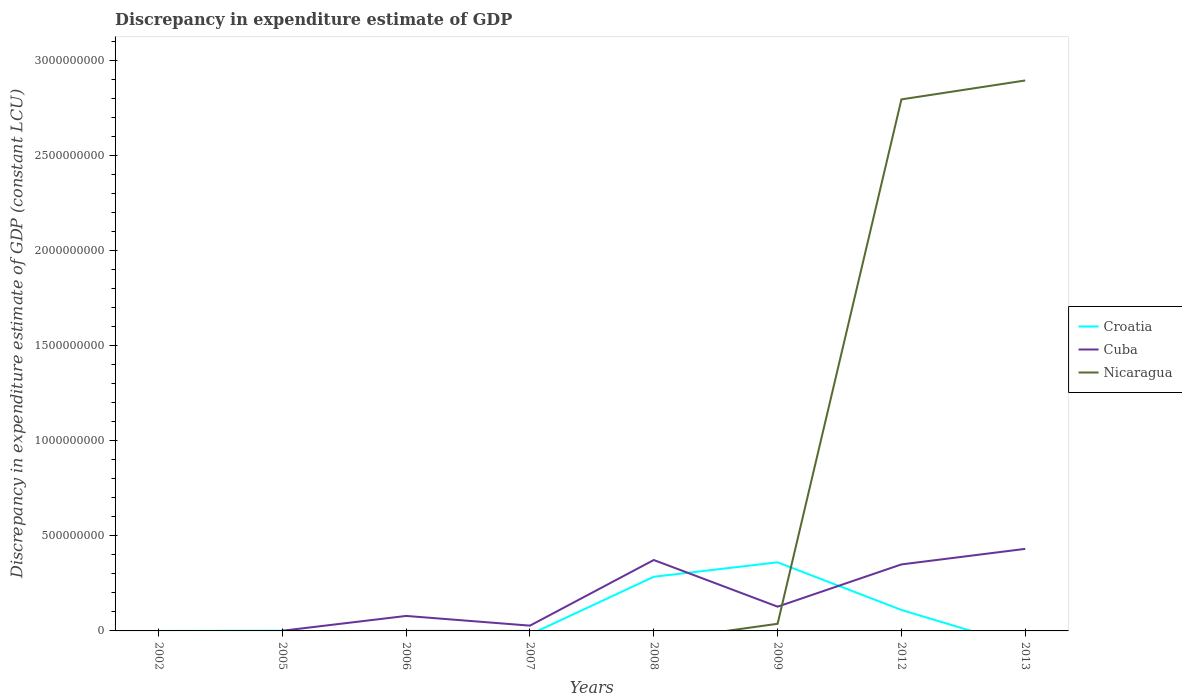How many different coloured lines are there?
Offer a very short reply. 3. Is the number of lines equal to the number of legend labels?
Make the answer very short. No. What is the total discrepancy in expenditure estimate of GDP in Cuba in the graph?
Offer a very short reply. -2.71e+08. What is the difference between the highest and the second highest discrepancy in expenditure estimate of GDP in Cuba?
Your response must be concise. 4.32e+08. Is the discrepancy in expenditure estimate of GDP in Nicaragua strictly greater than the discrepancy in expenditure estimate of GDP in Croatia over the years?
Offer a very short reply. No. How many years are there in the graph?
Offer a very short reply. 8. What is the difference between two consecutive major ticks on the Y-axis?
Make the answer very short. 5.00e+08. Does the graph contain any zero values?
Provide a succinct answer. Yes. What is the title of the graph?
Give a very brief answer. Discrepancy in expenditure estimate of GDP. What is the label or title of the Y-axis?
Your answer should be compact. Discrepancy in expenditure estimate of GDP (constant LCU). What is the Discrepancy in expenditure estimate of GDP (constant LCU) in Croatia in 2005?
Provide a short and direct response. 1.00e+06. What is the Discrepancy in expenditure estimate of GDP (constant LCU) of Cuba in 2005?
Your response must be concise. 9.00e+05. What is the Discrepancy in expenditure estimate of GDP (constant LCU) in Nicaragua in 2005?
Give a very brief answer. 0. What is the Discrepancy in expenditure estimate of GDP (constant LCU) in Cuba in 2006?
Offer a terse response. 7.89e+07. What is the Discrepancy in expenditure estimate of GDP (constant LCU) in Nicaragua in 2006?
Your answer should be compact. 0. What is the Discrepancy in expenditure estimate of GDP (constant LCU) of Cuba in 2007?
Your answer should be compact. 2.78e+07. What is the Discrepancy in expenditure estimate of GDP (constant LCU) in Croatia in 2008?
Provide a short and direct response. 2.85e+08. What is the Discrepancy in expenditure estimate of GDP (constant LCU) in Cuba in 2008?
Make the answer very short. 3.73e+08. What is the Discrepancy in expenditure estimate of GDP (constant LCU) in Nicaragua in 2008?
Give a very brief answer. 0. What is the Discrepancy in expenditure estimate of GDP (constant LCU) of Croatia in 2009?
Offer a terse response. 3.61e+08. What is the Discrepancy in expenditure estimate of GDP (constant LCU) of Cuba in 2009?
Give a very brief answer. 1.28e+08. What is the Discrepancy in expenditure estimate of GDP (constant LCU) of Nicaragua in 2009?
Your answer should be very brief. 3.76e+07. What is the Discrepancy in expenditure estimate of GDP (constant LCU) in Croatia in 2012?
Ensure brevity in your answer.  1.10e+08. What is the Discrepancy in expenditure estimate of GDP (constant LCU) in Cuba in 2012?
Make the answer very short. 3.50e+08. What is the Discrepancy in expenditure estimate of GDP (constant LCU) in Nicaragua in 2012?
Provide a succinct answer. 2.80e+09. What is the Discrepancy in expenditure estimate of GDP (constant LCU) of Croatia in 2013?
Your response must be concise. 0. What is the Discrepancy in expenditure estimate of GDP (constant LCU) in Cuba in 2013?
Offer a very short reply. 4.32e+08. What is the Discrepancy in expenditure estimate of GDP (constant LCU) in Nicaragua in 2013?
Make the answer very short. 2.90e+09. Across all years, what is the maximum Discrepancy in expenditure estimate of GDP (constant LCU) in Croatia?
Make the answer very short. 3.61e+08. Across all years, what is the maximum Discrepancy in expenditure estimate of GDP (constant LCU) in Cuba?
Provide a succinct answer. 4.32e+08. Across all years, what is the maximum Discrepancy in expenditure estimate of GDP (constant LCU) of Nicaragua?
Make the answer very short. 2.90e+09. Across all years, what is the minimum Discrepancy in expenditure estimate of GDP (constant LCU) of Croatia?
Provide a succinct answer. 0. Across all years, what is the minimum Discrepancy in expenditure estimate of GDP (constant LCU) in Nicaragua?
Your answer should be very brief. 0. What is the total Discrepancy in expenditure estimate of GDP (constant LCU) of Croatia in the graph?
Provide a succinct answer. 7.57e+08. What is the total Discrepancy in expenditure estimate of GDP (constant LCU) of Cuba in the graph?
Provide a succinct answer. 1.39e+09. What is the total Discrepancy in expenditure estimate of GDP (constant LCU) in Nicaragua in the graph?
Make the answer very short. 5.73e+09. What is the difference between the Discrepancy in expenditure estimate of GDP (constant LCU) in Croatia in 2002 and that in 2005?
Give a very brief answer. -1.00e+06. What is the difference between the Discrepancy in expenditure estimate of GDP (constant LCU) of Croatia in 2002 and that in 2008?
Your answer should be very brief. -2.85e+08. What is the difference between the Discrepancy in expenditure estimate of GDP (constant LCU) of Croatia in 2002 and that in 2009?
Offer a terse response. -3.61e+08. What is the difference between the Discrepancy in expenditure estimate of GDP (constant LCU) in Croatia in 2002 and that in 2012?
Your answer should be very brief. -1.10e+08. What is the difference between the Discrepancy in expenditure estimate of GDP (constant LCU) of Cuba in 2005 and that in 2006?
Provide a succinct answer. -7.80e+07. What is the difference between the Discrepancy in expenditure estimate of GDP (constant LCU) of Cuba in 2005 and that in 2007?
Provide a succinct answer. -2.69e+07. What is the difference between the Discrepancy in expenditure estimate of GDP (constant LCU) in Croatia in 2005 and that in 2008?
Ensure brevity in your answer.  -2.84e+08. What is the difference between the Discrepancy in expenditure estimate of GDP (constant LCU) of Cuba in 2005 and that in 2008?
Provide a succinct answer. -3.72e+08. What is the difference between the Discrepancy in expenditure estimate of GDP (constant LCU) in Croatia in 2005 and that in 2009?
Keep it short and to the point. -3.60e+08. What is the difference between the Discrepancy in expenditure estimate of GDP (constant LCU) of Cuba in 2005 and that in 2009?
Provide a succinct answer. -1.27e+08. What is the difference between the Discrepancy in expenditure estimate of GDP (constant LCU) in Croatia in 2005 and that in 2012?
Offer a very short reply. -1.09e+08. What is the difference between the Discrepancy in expenditure estimate of GDP (constant LCU) in Cuba in 2005 and that in 2012?
Offer a very short reply. -3.49e+08. What is the difference between the Discrepancy in expenditure estimate of GDP (constant LCU) of Cuba in 2005 and that in 2013?
Your answer should be very brief. -4.31e+08. What is the difference between the Discrepancy in expenditure estimate of GDP (constant LCU) in Cuba in 2006 and that in 2007?
Offer a terse response. 5.11e+07. What is the difference between the Discrepancy in expenditure estimate of GDP (constant LCU) in Cuba in 2006 and that in 2008?
Give a very brief answer. -2.94e+08. What is the difference between the Discrepancy in expenditure estimate of GDP (constant LCU) of Cuba in 2006 and that in 2009?
Your answer should be compact. -4.87e+07. What is the difference between the Discrepancy in expenditure estimate of GDP (constant LCU) of Cuba in 2006 and that in 2012?
Offer a terse response. -2.71e+08. What is the difference between the Discrepancy in expenditure estimate of GDP (constant LCU) of Cuba in 2006 and that in 2013?
Your answer should be very brief. -3.53e+08. What is the difference between the Discrepancy in expenditure estimate of GDP (constant LCU) of Cuba in 2007 and that in 2008?
Offer a very short reply. -3.45e+08. What is the difference between the Discrepancy in expenditure estimate of GDP (constant LCU) in Cuba in 2007 and that in 2009?
Offer a terse response. -9.98e+07. What is the difference between the Discrepancy in expenditure estimate of GDP (constant LCU) in Cuba in 2007 and that in 2012?
Keep it short and to the point. -3.22e+08. What is the difference between the Discrepancy in expenditure estimate of GDP (constant LCU) in Cuba in 2007 and that in 2013?
Your answer should be compact. -4.04e+08. What is the difference between the Discrepancy in expenditure estimate of GDP (constant LCU) of Croatia in 2008 and that in 2009?
Your answer should be compact. -7.60e+07. What is the difference between the Discrepancy in expenditure estimate of GDP (constant LCU) of Cuba in 2008 and that in 2009?
Provide a short and direct response. 2.45e+08. What is the difference between the Discrepancy in expenditure estimate of GDP (constant LCU) of Croatia in 2008 and that in 2012?
Offer a terse response. 1.74e+08. What is the difference between the Discrepancy in expenditure estimate of GDP (constant LCU) in Cuba in 2008 and that in 2012?
Offer a terse response. 2.32e+07. What is the difference between the Discrepancy in expenditure estimate of GDP (constant LCU) of Cuba in 2008 and that in 2013?
Ensure brevity in your answer.  -5.86e+07. What is the difference between the Discrepancy in expenditure estimate of GDP (constant LCU) in Croatia in 2009 and that in 2012?
Your response must be concise. 2.50e+08. What is the difference between the Discrepancy in expenditure estimate of GDP (constant LCU) of Cuba in 2009 and that in 2012?
Your response must be concise. -2.22e+08. What is the difference between the Discrepancy in expenditure estimate of GDP (constant LCU) in Nicaragua in 2009 and that in 2012?
Ensure brevity in your answer.  -2.76e+09. What is the difference between the Discrepancy in expenditure estimate of GDP (constant LCU) in Cuba in 2009 and that in 2013?
Make the answer very short. -3.04e+08. What is the difference between the Discrepancy in expenditure estimate of GDP (constant LCU) of Nicaragua in 2009 and that in 2013?
Provide a short and direct response. -2.86e+09. What is the difference between the Discrepancy in expenditure estimate of GDP (constant LCU) of Cuba in 2012 and that in 2013?
Provide a succinct answer. -8.18e+07. What is the difference between the Discrepancy in expenditure estimate of GDP (constant LCU) of Nicaragua in 2012 and that in 2013?
Give a very brief answer. -9.95e+07. What is the difference between the Discrepancy in expenditure estimate of GDP (constant LCU) in Croatia in 2002 and the Discrepancy in expenditure estimate of GDP (constant LCU) in Cuba in 2005?
Make the answer very short. -9.00e+05. What is the difference between the Discrepancy in expenditure estimate of GDP (constant LCU) in Croatia in 2002 and the Discrepancy in expenditure estimate of GDP (constant LCU) in Cuba in 2006?
Your answer should be very brief. -7.89e+07. What is the difference between the Discrepancy in expenditure estimate of GDP (constant LCU) in Croatia in 2002 and the Discrepancy in expenditure estimate of GDP (constant LCU) in Cuba in 2007?
Provide a succinct answer. -2.78e+07. What is the difference between the Discrepancy in expenditure estimate of GDP (constant LCU) in Croatia in 2002 and the Discrepancy in expenditure estimate of GDP (constant LCU) in Cuba in 2008?
Make the answer very short. -3.73e+08. What is the difference between the Discrepancy in expenditure estimate of GDP (constant LCU) in Croatia in 2002 and the Discrepancy in expenditure estimate of GDP (constant LCU) in Cuba in 2009?
Keep it short and to the point. -1.28e+08. What is the difference between the Discrepancy in expenditure estimate of GDP (constant LCU) of Croatia in 2002 and the Discrepancy in expenditure estimate of GDP (constant LCU) of Nicaragua in 2009?
Provide a succinct answer. -3.76e+07. What is the difference between the Discrepancy in expenditure estimate of GDP (constant LCU) in Croatia in 2002 and the Discrepancy in expenditure estimate of GDP (constant LCU) in Cuba in 2012?
Offer a very short reply. -3.50e+08. What is the difference between the Discrepancy in expenditure estimate of GDP (constant LCU) in Croatia in 2002 and the Discrepancy in expenditure estimate of GDP (constant LCU) in Nicaragua in 2012?
Provide a short and direct response. -2.80e+09. What is the difference between the Discrepancy in expenditure estimate of GDP (constant LCU) in Croatia in 2002 and the Discrepancy in expenditure estimate of GDP (constant LCU) in Cuba in 2013?
Make the answer very short. -4.32e+08. What is the difference between the Discrepancy in expenditure estimate of GDP (constant LCU) in Croatia in 2002 and the Discrepancy in expenditure estimate of GDP (constant LCU) in Nicaragua in 2013?
Ensure brevity in your answer.  -2.90e+09. What is the difference between the Discrepancy in expenditure estimate of GDP (constant LCU) of Croatia in 2005 and the Discrepancy in expenditure estimate of GDP (constant LCU) of Cuba in 2006?
Give a very brief answer. -7.79e+07. What is the difference between the Discrepancy in expenditure estimate of GDP (constant LCU) of Croatia in 2005 and the Discrepancy in expenditure estimate of GDP (constant LCU) of Cuba in 2007?
Provide a short and direct response. -2.68e+07. What is the difference between the Discrepancy in expenditure estimate of GDP (constant LCU) in Croatia in 2005 and the Discrepancy in expenditure estimate of GDP (constant LCU) in Cuba in 2008?
Your answer should be very brief. -3.72e+08. What is the difference between the Discrepancy in expenditure estimate of GDP (constant LCU) in Croatia in 2005 and the Discrepancy in expenditure estimate of GDP (constant LCU) in Cuba in 2009?
Your answer should be very brief. -1.27e+08. What is the difference between the Discrepancy in expenditure estimate of GDP (constant LCU) in Croatia in 2005 and the Discrepancy in expenditure estimate of GDP (constant LCU) in Nicaragua in 2009?
Your answer should be compact. -3.66e+07. What is the difference between the Discrepancy in expenditure estimate of GDP (constant LCU) of Cuba in 2005 and the Discrepancy in expenditure estimate of GDP (constant LCU) of Nicaragua in 2009?
Provide a short and direct response. -3.67e+07. What is the difference between the Discrepancy in expenditure estimate of GDP (constant LCU) in Croatia in 2005 and the Discrepancy in expenditure estimate of GDP (constant LCU) in Cuba in 2012?
Offer a very short reply. -3.49e+08. What is the difference between the Discrepancy in expenditure estimate of GDP (constant LCU) in Croatia in 2005 and the Discrepancy in expenditure estimate of GDP (constant LCU) in Nicaragua in 2012?
Offer a terse response. -2.80e+09. What is the difference between the Discrepancy in expenditure estimate of GDP (constant LCU) of Cuba in 2005 and the Discrepancy in expenditure estimate of GDP (constant LCU) of Nicaragua in 2012?
Your answer should be very brief. -2.80e+09. What is the difference between the Discrepancy in expenditure estimate of GDP (constant LCU) of Croatia in 2005 and the Discrepancy in expenditure estimate of GDP (constant LCU) of Cuba in 2013?
Offer a very short reply. -4.31e+08. What is the difference between the Discrepancy in expenditure estimate of GDP (constant LCU) of Croatia in 2005 and the Discrepancy in expenditure estimate of GDP (constant LCU) of Nicaragua in 2013?
Give a very brief answer. -2.89e+09. What is the difference between the Discrepancy in expenditure estimate of GDP (constant LCU) in Cuba in 2005 and the Discrepancy in expenditure estimate of GDP (constant LCU) in Nicaragua in 2013?
Ensure brevity in your answer.  -2.89e+09. What is the difference between the Discrepancy in expenditure estimate of GDP (constant LCU) of Cuba in 2006 and the Discrepancy in expenditure estimate of GDP (constant LCU) of Nicaragua in 2009?
Offer a very short reply. 4.12e+07. What is the difference between the Discrepancy in expenditure estimate of GDP (constant LCU) in Cuba in 2006 and the Discrepancy in expenditure estimate of GDP (constant LCU) in Nicaragua in 2012?
Your answer should be very brief. -2.72e+09. What is the difference between the Discrepancy in expenditure estimate of GDP (constant LCU) in Cuba in 2006 and the Discrepancy in expenditure estimate of GDP (constant LCU) in Nicaragua in 2013?
Provide a succinct answer. -2.82e+09. What is the difference between the Discrepancy in expenditure estimate of GDP (constant LCU) in Cuba in 2007 and the Discrepancy in expenditure estimate of GDP (constant LCU) in Nicaragua in 2009?
Your answer should be very brief. -9.83e+06. What is the difference between the Discrepancy in expenditure estimate of GDP (constant LCU) in Cuba in 2007 and the Discrepancy in expenditure estimate of GDP (constant LCU) in Nicaragua in 2012?
Your answer should be very brief. -2.77e+09. What is the difference between the Discrepancy in expenditure estimate of GDP (constant LCU) of Cuba in 2007 and the Discrepancy in expenditure estimate of GDP (constant LCU) of Nicaragua in 2013?
Provide a short and direct response. -2.87e+09. What is the difference between the Discrepancy in expenditure estimate of GDP (constant LCU) in Croatia in 2008 and the Discrepancy in expenditure estimate of GDP (constant LCU) in Cuba in 2009?
Provide a succinct answer. 1.57e+08. What is the difference between the Discrepancy in expenditure estimate of GDP (constant LCU) in Croatia in 2008 and the Discrepancy in expenditure estimate of GDP (constant LCU) in Nicaragua in 2009?
Keep it short and to the point. 2.47e+08. What is the difference between the Discrepancy in expenditure estimate of GDP (constant LCU) in Cuba in 2008 and the Discrepancy in expenditure estimate of GDP (constant LCU) in Nicaragua in 2009?
Your response must be concise. 3.35e+08. What is the difference between the Discrepancy in expenditure estimate of GDP (constant LCU) of Croatia in 2008 and the Discrepancy in expenditure estimate of GDP (constant LCU) of Cuba in 2012?
Provide a short and direct response. -6.50e+07. What is the difference between the Discrepancy in expenditure estimate of GDP (constant LCU) in Croatia in 2008 and the Discrepancy in expenditure estimate of GDP (constant LCU) in Nicaragua in 2012?
Ensure brevity in your answer.  -2.51e+09. What is the difference between the Discrepancy in expenditure estimate of GDP (constant LCU) of Cuba in 2008 and the Discrepancy in expenditure estimate of GDP (constant LCU) of Nicaragua in 2012?
Offer a terse response. -2.42e+09. What is the difference between the Discrepancy in expenditure estimate of GDP (constant LCU) in Croatia in 2008 and the Discrepancy in expenditure estimate of GDP (constant LCU) in Cuba in 2013?
Make the answer very short. -1.47e+08. What is the difference between the Discrepancy in expenditure estimate of GDP (constant LCU) in Croatia in 2008 and the Discrepancy in expenditure estimate of GDP (constant LCU) in Nicaragua in 2013?
Keep it short and to the point. -2.61e+09. What is the difference between the Discrepancy in expenditure estimate of GDP (constant LCU) in Cuba in 2008 and the Discrepancy in expenditure estimate of GDP (constant LCU) in Nicaragua in 2013?
Your response must be concise. -2.52e+09. What is the difference between the Discrepancy in expenditure estimate of GDP (constant LCU) in Croatia in 2009 and the Discrepancy in expenditure estimate of GDP (constant LCU) in Cuba in 2012?
Give a very brief answer. 1.09e+07. What is the difference between the Discrepancy in expenditure estimate of GDP (constant LCU) of Croatia in 2009 and the Discrepancy in expenditure estimate of GDP (constant LCU) of Nicaragua in 2012?
Offer a very short reply. -2.44e+09. What is the difference between the Discrepancy in expenditure estimate of GDP (constant LCU) of Cuba in 2009 and the Discrepancy in expenditure estimate of GDP (constant LCU) of Nicaragua in 2012?
Your answer should be very brief. -2.67e+09. What is the difference between the Discrepancy in expenditure estimate of GDP (constant LCU) of Croatia in 2009 and the Discrepancy in expenditure estimate of GDP (constant LCU) of Cuba in 2013?
Provide a short and direct response. -7.08e+07. What is the difference between the Discrepancy in expenditure estimate of GDP (constant LCU) in Croatia in 2009 and the Discrepancy in expenditure estimate of GDP (constant LCU) in Nicaragua in 2013?
Keep it short and to the point. -2.53e+09. What is the difference between the Discrepancy in expenditure estimate of GDP (constant LCU) of Cuba in 2009 and the Discrepancy in expenditure estimate of GDP (constant LCU) of Nicaragua in 2013?
Offer a terse response. -2.77e+09. What is the difference between the Discrepancy in expenditure estimate of GDP (constant LCU) of Croatia in 2012 and the Discrepancy in expenditure estimate of GDP (constant LCU) of Cuba in 2013?
Offer a terse response. -3.21e+08. What is the difference between the Discrepancy in expenditure estimate of GDP (constant LCU) of Croatia in 2012 and the Discrepancy in expenditure estimate of GDP (constant LCU) of Nicaragua in 2013?
Make the answer very short. -2.79e+09. What is the difference between the Discrepancy in expenditure estimate of GDP (constant LCU) in Cuba in 2012 and the Discrepancy in expenditure estimate of GDP (constant LCU) in Nicaragua in 2013?
Ensure brevity in your answer.  -2.55e+09. What is the average Discrepancy in expenditure estimate of GDP (constant LCU) in Croatia per year?
Provide a succinct answer. 9.46e+07. What is the average Discrepancy in expenditure estimate of GDP (constant LCU) of Cuba per year?
Provide a succinct answer. 1.74e+08. What is the average Discrepancy in expenditure estimate of GDP (constant LCU) of Nicaragua per year?
Ensure brevity in your answer.  7.16e+08. In the year 2008, what is the difference between the Discrepancy in expenditure estimate of GDP (constant LCU) of Croatia and Discrepancy in expenditure estimate of GDP (constant LCU) of Cuba?
Your answer should be compact. -8.82e+07. In the year 2009, what is the difference between the Discrepancy in expenditure estimate of GDP (constant LCU) in Croatia and Discrepancy in expenditure estimate of GDP (constant LCU) in Cuba?
Your answer should be very brief. 2.33e+08. In the year 2009, what is the difference between the Discrepancy in expenditure estimate of GDP (constant LCU) of Croatia and Discrepancy in expenditure estimate of GDP (constant LCU) of Nicaragua?
Your response must be concise. 3.23e+08. In the year 2009, what is the difference between the Discrepancy in expenditure estimate of GDP (constant LCU) in Cuba and Discrepancy in expenditure estimate of GDP (constant LCU) in Nicaragua?
Your response must be concise. 9.00e+07. In the year 2012, what is the difference between the Discrepancy in expenditure estimate of GDP (constant LCU) in Croatia and Discrepancy in expenditure estimate of GDP (constant LCU) in Cuba?
Offer a terse response. -2.39e+08. In the year 2012, what is the difference between the Discrepancy in expenditure estimate of GDP (constant LCU) in Croatia and Discrepancy in expenditure estimate of GDP (constant LCU) in Nicaragua?
Provide a short and direct response. -2.69e+09. In the year 2012, what is the difference between the Discrepancy in expenditure estimate of GDP (constant LCU) in Cuba and Discrepancy in expenditure estimate of GDP (constant LCU) in Nicaragua?
Offer a terse response. -2.45e+09. In the year 2013, what is the difference between the Discrepancy in expenditure estimate of GDP (constant LCU) of Cuba and Discrepancy in expenditure estimate of GDP (constant LCU) of Nicaragua?
Ensure brevity in your answer.  -2.46e+09. What is the ratio of the Discrepancy in expenditure estimate of GDP (constant LCU) of Croatia in 2002 to that in 2005?
Provide a succinct answer. 0. What is the ratio of the Discrepancy in expenditure estimate of GDP (constant LCU) of Croatia in 2002 to that in 2009?
Keep it short and to the point. 0. What is the ratio of the Discrepancy in expenditure estimate of GDP (constant LCU) in Croatia in 2002 to that in 2012?
Provide a short and direct response. 0. What is the ratio of the Discrepancy in expenditure estimate of GDP (constant LCU) of Cuba in 2005 to that in 2006?
Offer a very short reply. 0.01. What is the ratio of the Discrepancy in expenditure estimate of GDP (constant LCU) in Cuba in 2005 to that in 2007?
Your answer should be very brief. 0.03. What is the ratio of the Discrepancy in expenditure estimate of GDP (constant LCU) of Croatia in 2005 to that in 2008?
Offer a very short reply. 0. What is the ratio of the Discrepancy in expenditure estimate of GDP (constant LCU) of Cuba in 2005 to that in 2008?
Keep it short and to the point. 0. What is the ratio of the Discrepancy in expenditure estimate of GDP (constant LCU) of Croatia in 2005 to that in 2009?
Provide a short and direct response. 0. What is the ratio of the Discrepancy in expenditure estimate of GDP (constant LCU) of Cuba in 2005 to that in 2009?
Your response must be concise. 0.01. What is the ratio of the Discrepancy in expenditure estimate of GDP (constant LCU) of Croatia in 2005 to that in 2012?
Your answer should be compact. 0.01. What is the ratio of the Discrepancy in expenditure estimate of GDP (constant LCU) of Cuba in 2005 to that in 2012?
Offer a terse response. 0. What is the ratio of the Discrepancy in expenditure estimate of GDP (constant LCU) of Cuba in 2005 to that in 2013?
Your answer should be compact. 0. What is the ratio of the Discrepancy in expenditure estimate of GDP (constant LCU) in Cuba in 2006 to that in 2007?
Provide a succinct answer. 2.84. What is the ratio of the Discrepancy in expenditure estimate of GDP (constant LCU) in Cuba in 2006 to that in 2008?
Provide a succinct answer. 0.21. What is the ratio of the Discrepancy in expenditure estimate of GDP (constant LCU) in Cuba in 2006 to that in 2009?
Offer a terse response. 0.62. What is the ratio of the Discrepancy in expenditure estimate of GDP (constant LCU) in Cuba in 2006 to that in 2012?
Your response must be concise. 0.23. What is the ratio of the Discrepancy in expenditure estimate of GDP (constant LCU) of Cuba in 2006 to that in 2013?
Provide a short and direct response. 0.18. What is the ratio of the Discrepancy in expenditure estimate of GDP (constant LCU) of Cuba in 2007 to that in 2008?
Ensure brevity in your answer.  0.07. What is the ratio of the Discrepancy in expenditure estimate of GDP (constant LCU) of Cuba in 2007 to that in 2009?
Offer a terse response. 0.22. What is the ratio of the Discrepancy in expenditure estimate of GDP (constant LCU) in Cuba in 2007 to that in 2012?
Provide a short and direct response. 0.08. What is the ratio of the Discrepancy in expenditure estimate of GDP (constant LCU) in Cuba in 2007 to that in 2013?
Your response must be concise. 0.06. What is the ratio of the Discrepancy in expenditure estimate of GDP (constant LCU) of Croatia in 2008 to that in 2009?
Offer a very short reply. 0.79. What is the ratio of the Discrepancy in expenditure estimate of GDP (constant LCU) in Cuba in 2008 to that in 2009?
Ensure brevity in your answer.  2.92. What is the ratio of the Discrepancy in expenditure estimate of GDP (constant LCU) of Croatia in 2008 to that in 2012?
Your answer should be compact. 2.58. What is the ratio of the Discrepancy in expenditure estimate of GDP (constant LCU) in Cuba in 2008 to that in 2012?
Give a very brief answer. 1.07. What is the ratio of the Discrepancy in expenditure estimate of GDP (constant LCU) of Cuba in 2008 to that in 2013?
Your answer should be compact. 0.86. What is the ratio of the Discrepancy in expenditure estimate of GDP (constant LCU) in Croatia in 2009 to that in 2012?
Ensure brevity in your answer.  3.27. What is the ratio of the Discrepancy in expenditure estimate of GDP (constant LCU) in Cuba in 2009 to that in 2012?
Keep it short and to the point. 0.36. What is the ratio of the Discrepancy in expenditure estimate of GDP (constant LCU) in Nicaragua in 2009 to that in 2012?
Give a very brief answer. 0.01. What is the ratio of the Discrepancy in expenditure estimate of GDP (constant LCU) of Cuba in 2009 to that in 2013?
Your response must be concise. 0.3. What is the ratio of the Discrepancy in expenditure estimate of GDP (constant LCU) in Nicaragua in 2009 to that in 2013?
Keep it short and to the point. 0.01. What is the ratio of the Discrepancy in expenditure estimate of GDP (constant LCU) of Cuba in 2012 to that in 2013?
Give a very brief answer. 0.81. What is the ratio of the Discrepancy in expenditure estimate of GDP (constant LCU) of Nicaragua in 2012 to that in 2013?
Your response must be concise. 0.97. What is the difference between the highest and the second highest Discrepancy in expenditure estimate of GDP (constant LCU) in Croatia?
Your response must be concise. 7.60e+07. What is the difference between the highest and the second highest Discrepancy in expenditure estimate of GDP (constant LCU) in Cuba?
Offer a terse response. 5.86e+07. What is the difference between the highest and the second highest Discrepancy in expenditure estimate of GDP (constant LCU) in Nicaragua?
Your answer should be compact. 9.95e+07. What is the difference between the highest and the lowest Discrepancy in expenditure estimate of GDP (constant LCU) in Croatia?
Give a very brief answer. 3.61e+08. What is the difference between the highest and the lowest Discrepancy in expenditure estimate of GDP (constant LCU) of Cuba?
Offer a very short reply. 4.32e+08. What is the difference between the highest and the lowest Discrepancy in expenditure estimate of GDP (constant LCU) in Nicaragua?
Provide a succinct answer. 2.90e+09. 